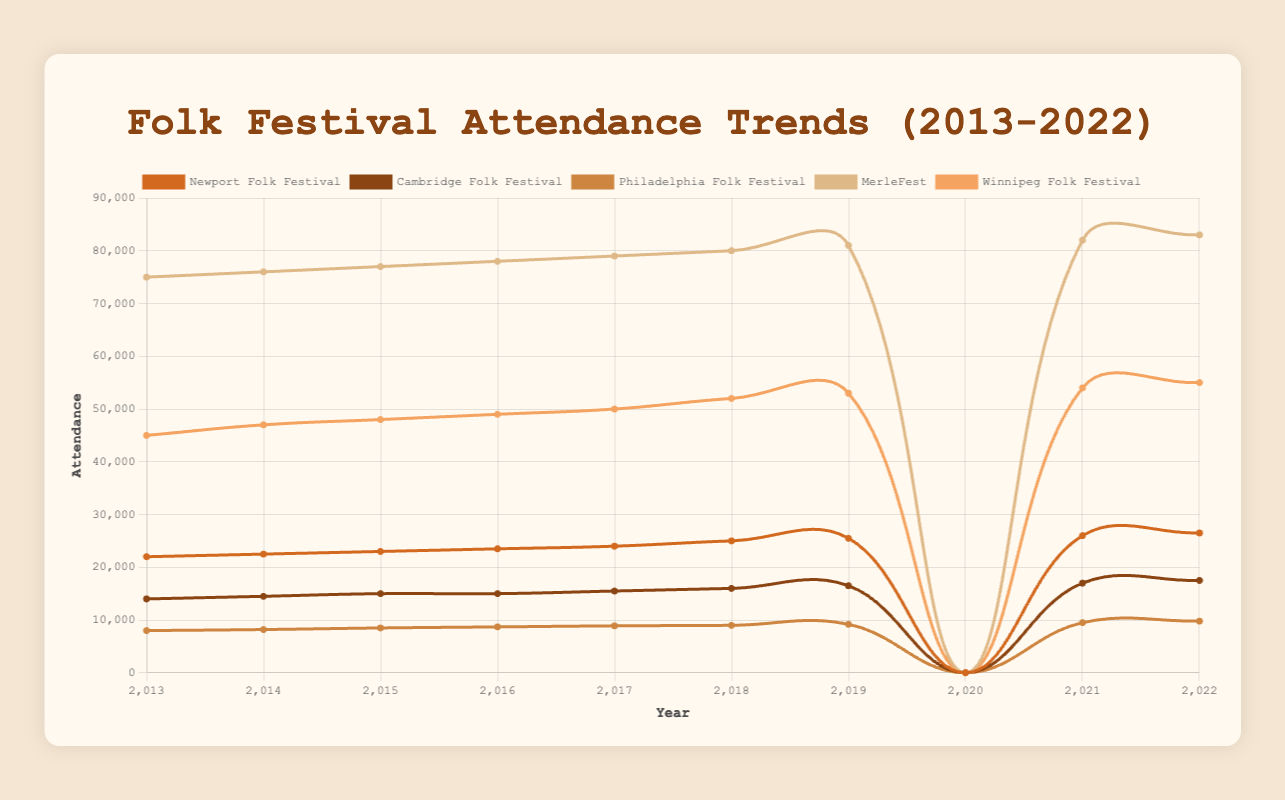Which festival had the highest attendance in 2022? By looking at the end of the visual chart for the year 2022, we can compare the attendance values of each festival. The line for MerleFest reaches the highest point on the y-axis.
Answer: MerleFest Which festival showed the most consistent growth in attendance from 2013 to 2022, excluding 2020? Consistent growth means that the attendance increases steadily each year. By examining the slopes of the lines for each festival, it's apparent that both Newport Folk Festival and Winnipeg Folk Festival show a steady increase, but Winnipeg Folk Festival's slope is steadier overall.
Answer: Winnipeg Folk Festival How did the attendance of Philadelphia Folk Festival change between 2017 and 2019? To find this, observe the Philadelphia Folk Festival line from 2017 to 2019. The attendance increased from 8900 in 2017 to 9200 in 2019. The difference is 9200 - 8900.
Answer: Increased by 300 What was the average attendance at the Newport Folk Festival from 2013 to 2022, excluding 2020? Calculate the sum of Newport Folk Festival's attendance from 2013-2022 (excluding 2020) and divide by the number of years. Sum = 22000 + 22500 + 23000 + 23500 + 24000 + 25000 + 25500 + 26000 + 26500 = 218000. Divide the sum by 9: 218000/9.
Answer: 24222.2 How much more was the attendance at MerleFest in 2022 compared to 2013? Find the attendance numbers for MerleFest in 2013 and 2022, and subtract the former from the latter. Attendance in 2013 was 75000, and in 2022 it was 83000. So, 83000 - 75000.
Answer: 8000 Which festival showed a drop in attendance or had zero attendance in 2020? By observing the plot for the year 2020, all lines drop to zero, indicating all festivals had zero attendance in 2020.
Answer: All festivals Compare the attendance of the Cambridge Folk Festival and Philadelphia Folk Festival in 2021. Which had more attendees, and by how much? Check the attendance values for both festivals in 2021. Cambridge Folk Festival had 17000 attendees, and Philadelphia Folk Festival had 9500. Subtract the latter from the former, 17000 - 9500.
Answer: Cambridge Folk Festival by 7500 What is the total attendance for all festivals combined in 2022? Sum up the attendance numbers for each festival in 2022: Newport Folk Festival (26500) + Cambridge Folk Festival (17500) + Philadelphia Folk Festival (9800) + MerleFest (83000) + Winnipeg Folk Festival (55000). Total is 26500 + 17500 + 9800 + 83000 + 55000.
Answer: 191800 What's the difference in growth rate between Newport Folk Festival and MerleFest from 2013 to 2022? Calculate the growth rate by subtracting the initial value in 2013 from the final value in 2022 and then divide by the number of years (exclude 2020). For Newport Folk Festival: (26500-22000)/9 = 500. For MerleFest: (83000-75000)/9 = 888.89. Difference is 888.89-500.
Answer: 388.89 